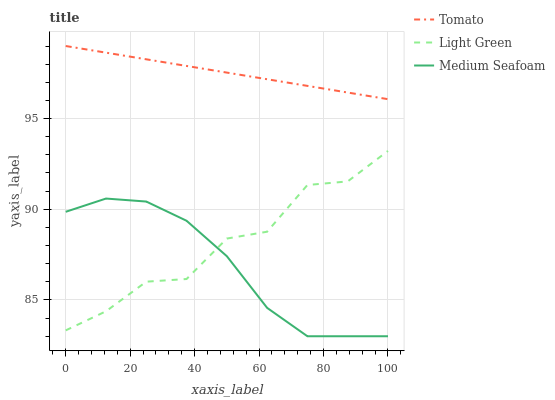Does Medium Seafoam have the minimum area under the curve?
Answer yes or no. Yes. Does Tomato have the maximum area under the curve?
Answer yes or no. Yes. Does Light Green have the minimum area under the curve?
Answer yes or no. No. Does Light Green have the maximum area under the curve?
Answer yes or no. No. Is Tomato the smoothest?
Answer yes or no. Yes. Is Light Green the roughest?
Answer yes or no. Yes. Is Medium Seafoam the smoothest?
Answer yes or no. No. Is Medium Seafoam the roughest?
Answer yes or no. No. Does Medium Seafoam have the lowest value?
Answer yes or no. Yes. Does Light Green have the lowest value?
Answer yes or no. No. Does Tomato have the highest value?
Answer yes or no. Yes. Does Light Green have the highest value?
Answer yes or no. No. Is Light Green less than Tomato?
Answer yes or no. Yes. Is Tomato greater than Medium Seafoam?
Answer yes or no. Yes. Does Medium Seafoam intersect Light Green?
Answer yes or no. Yes. Is Medium Seafoam less than Light Green?
Answer yes or no. No. Is Medium Seafoam greater than Light Green?
Answer yes or no. No. Does Light Green intersect Tomato?
Answer yes or no. No. 